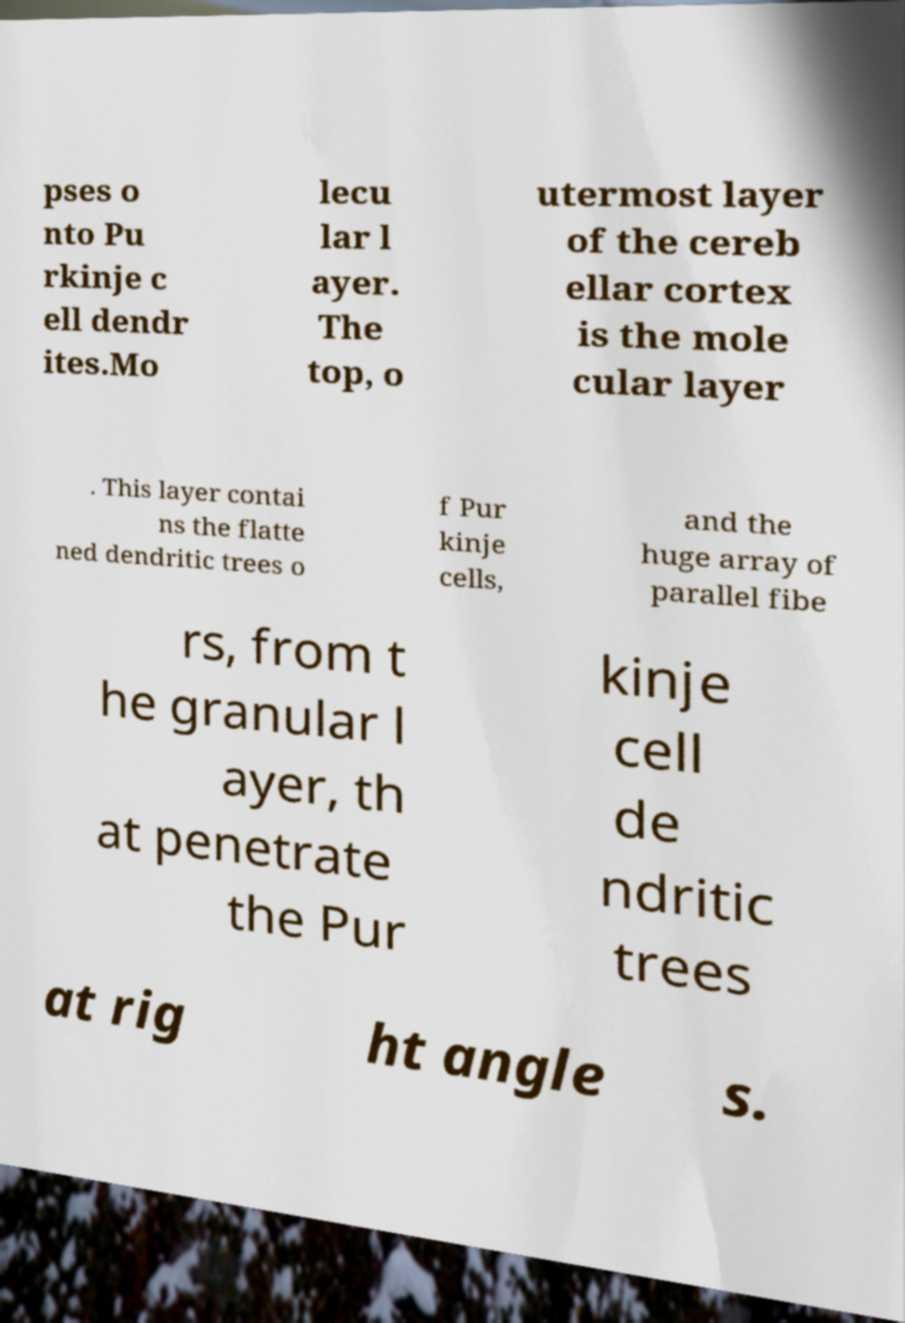What messages or text are displayed in this image? I need them in a readable, typed format. pses o nto Pu rkinje c ell dendr ites.Mo lecu lar l ayer. The top, o utermost layer of the cereb ellar cortex is the mole cular layer . This layer contai ns the flatte ned dendritic trees o f Pur kinje cells, and the huge array of parallel fibe rs, from t he granular l ayer, th at penetrate the Pur kinje cell de ndritic trees at rig ht angle s. 